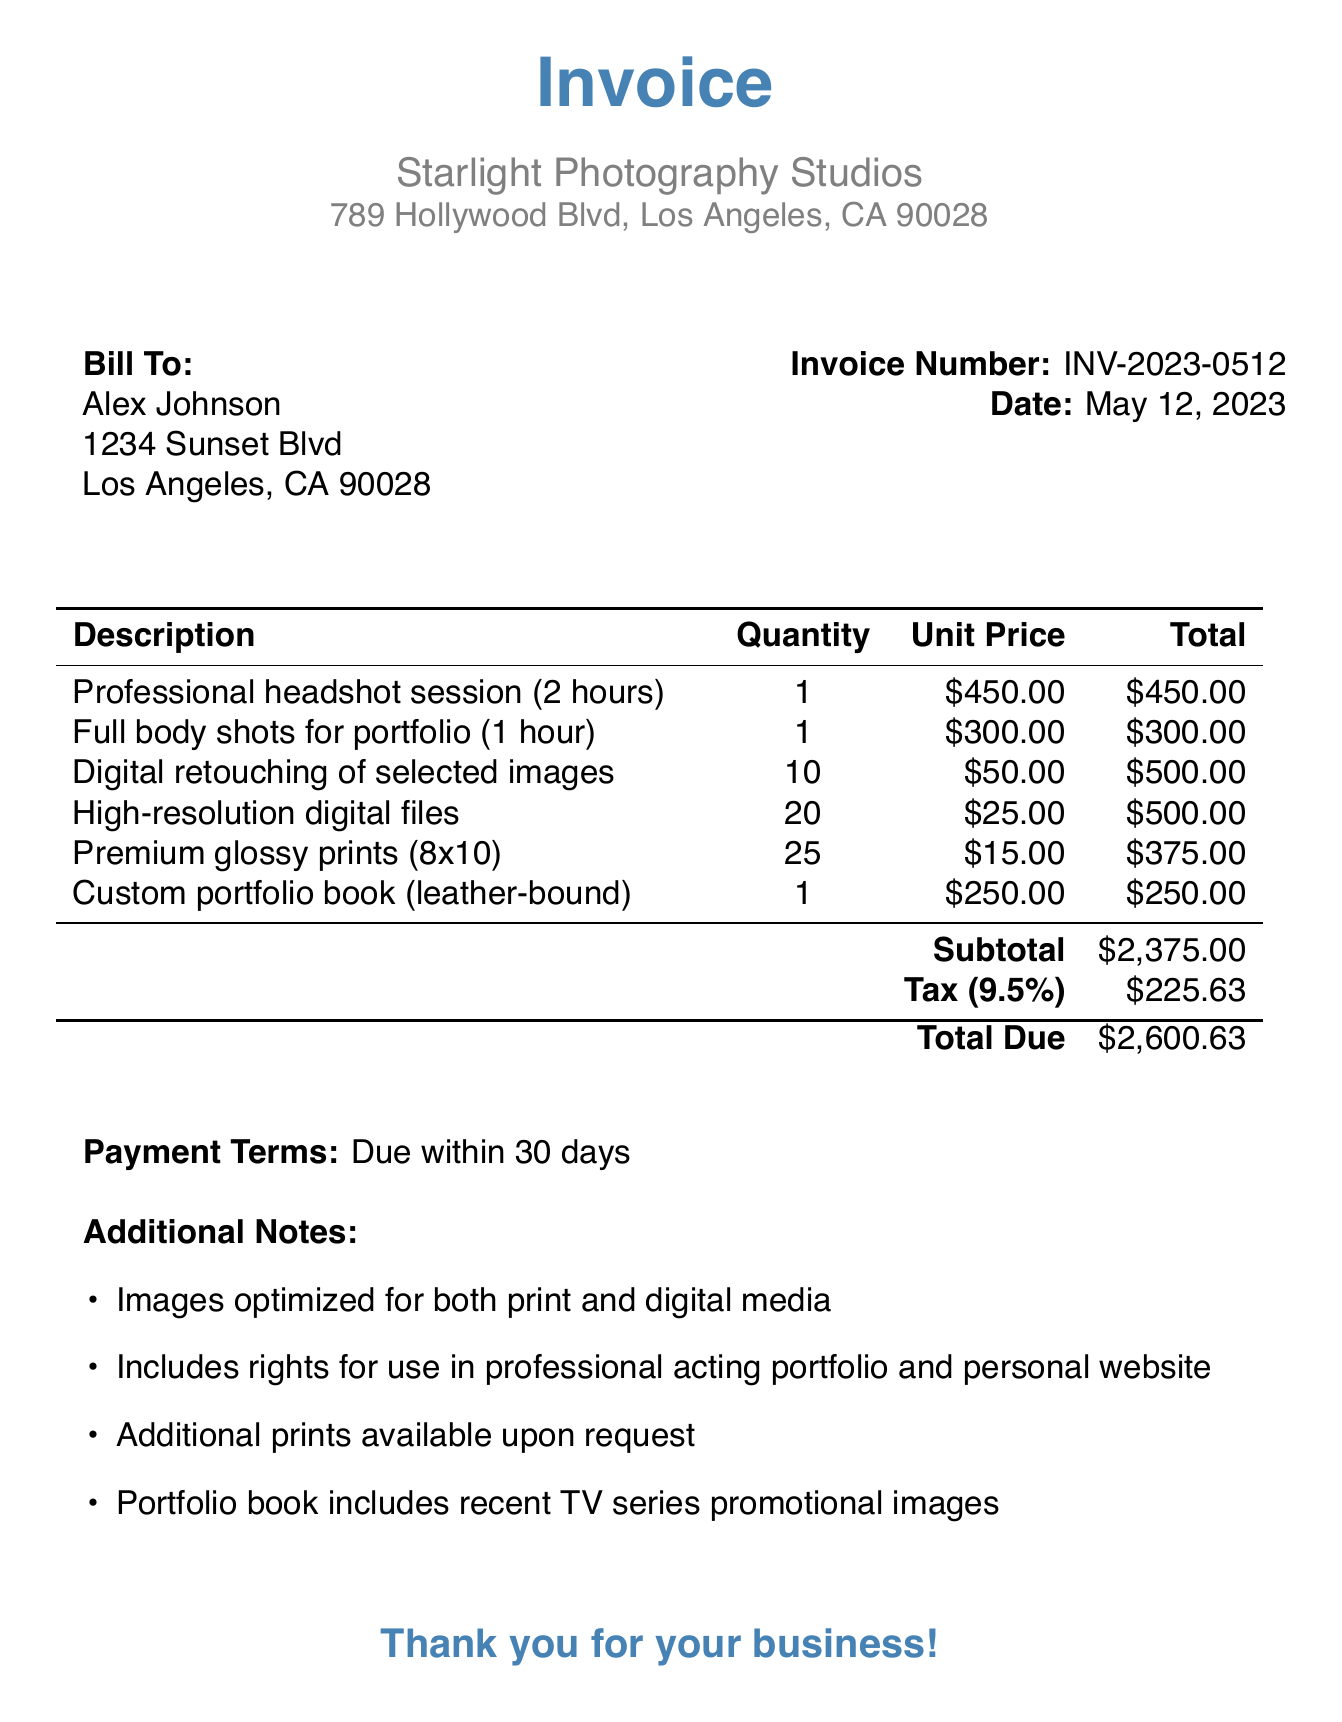What is the invoice number? The invoice number is labeled in the document for easy identification, specifically "INV-2023-0512".
Answer: INV-2023-0512 Who is the photographer? The photographer's name appears at the top of the invoice and identifies the service provider as "Emma Rodriguez".
Answer: Emma Rodriguez What is the total due amount? The total due amount is calculated including the subtotal and tax, listed as "$2600.63".
Answer: $2600.63 How many digital retouching services were provided? The quantity of digital retouching services in the itemized list indicates a total of "10".
Answer: 10 What is the tax rate applied? The tax rate applied is mentioned in the subtotal section and stated clearly as "9.5%".
Answer: 9.5% What type of portfolio book is included? The portfolio book description specifies it as "leather-bound".
Answer: leather-bound When is the payment due? The payment terms section indicates that payment is "Due within 30 days".
Answer: Due within 30 days How many high-resolution digital files were provided? In the detailed item list, it is specified that "20" high-resolution digital files are included.
Answer: 20 What is included in the additional notes? The additional notes provide key details about the services and usages, such as optimization for print and digital media.
Answer: Images optimized for both print and digital media 